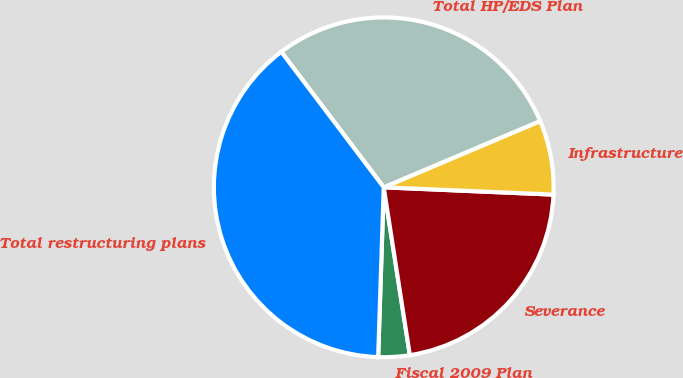Convert chart to OTSL. <chart><loc_0><loc_0><loc_500><loc_500><pie_chart><fcel>Fiscal 2009 Plan<fcel>Severance<fcel>Infrastructure<fcel>Total HP/EDS Plan<fcel>Total restructuring plans<nl><fcel>2.98%<fcel>21.86%<fcel>7.06%<fcel>28.93%<fcel>39.17%<nl></chart> 